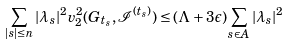Convert formula to latex. <formula><loc_0><loc_0><loc_500><loc_500>\sum _ { | s | \leq n } | \lambda _ { s } | ^ { 2 } v _ { 2 } ^ { 2 } ( G _ { t _ { s } } , \mathcal { I } ^ { ( t _ { s } ) } ) \leq ( \Lambda + 3 \epsilon ) \sum _ { s \in A } | \lambda _ { s } | ^ { 2 }</formula> 